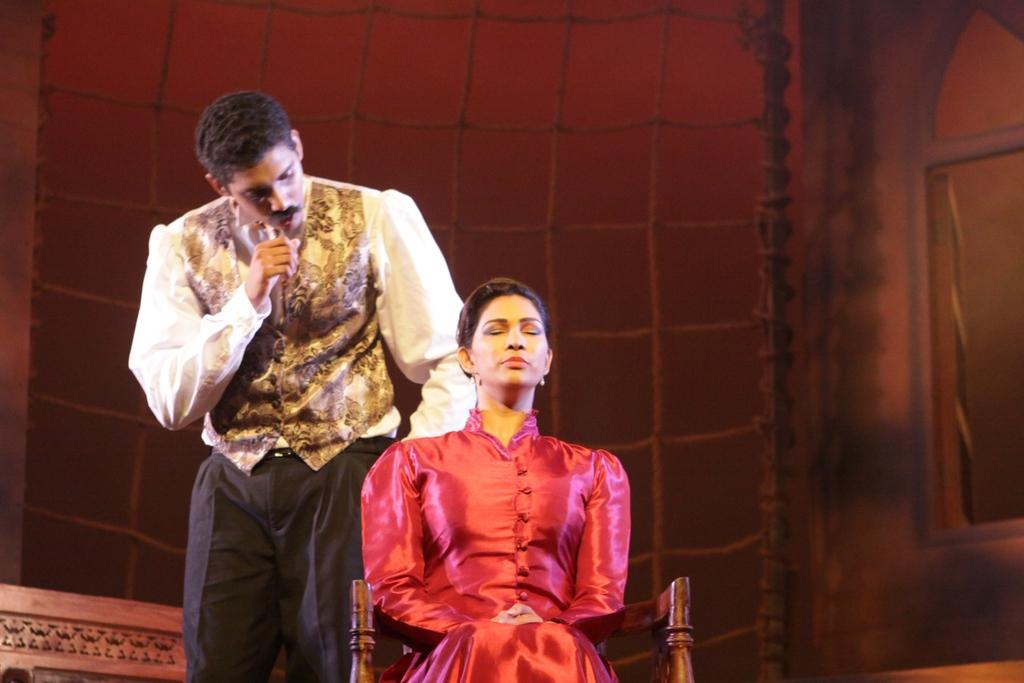How many people are in the image? There are two people in the image, one standing and one sitting on a chair. What is the color of the background in the image? The background color is brown. What can be seen in the background of the image? There are objects visible in the background of the image. Can you see any sugar on the sidewalk in the image? There is no sidewalk or sugar present in the image. What type of clouds can be seen in the image? There are no clouds visible in the image. 